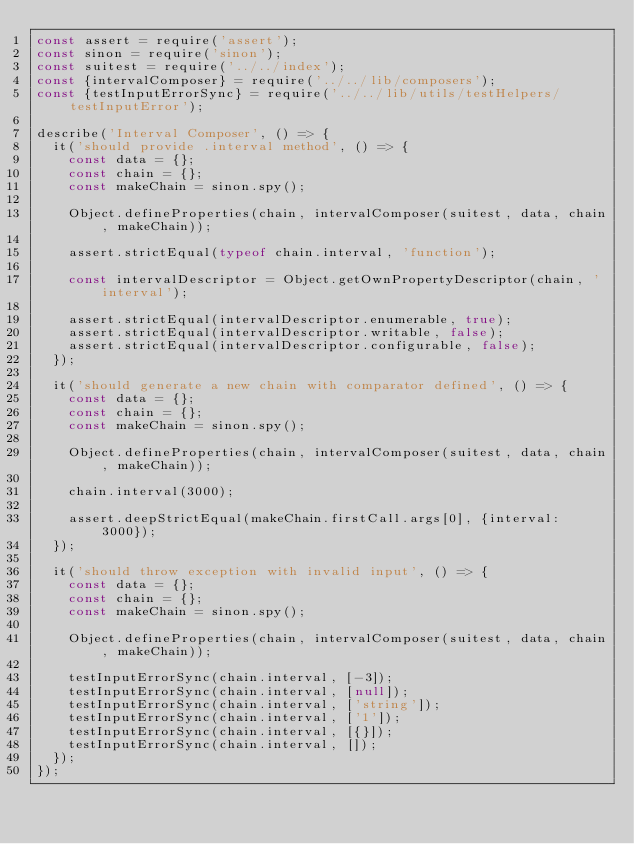Convert code to text. <code><loc_0><loc_0><loc_500><loc_500><_JavaScript_>const assert = require('assert');
const sinon = require('sinon');
const suitest = require('../../index');
const {intervalComposer} = require('../../lib/composers');
const {testInputErrorSync} = require('../../lib/utils/testHelpers/testInputError');

describe('Interval Composer', () => {
	it('should provide .interval method', () => {
		const data = {};
		const chain = {};
		const makeChain = sinon.spy();

		Object.defineProperties(chain, intervalComposer(suitest, data, chain, makeChain));

		assert.strictEqual(typeof chain.interval, 'function');

		const intervalDescriptor = Object.getOwnPropertyDescriptor(chain, 'interval');

		assert.strictEqual(intervalDescriptor.enumerable, true);
		assert.strictEqual(intervalDescriptor.writable, false);
		assert.strictEqual(intervalDescriptor.configurable, false);
	});

	it('should generate a new chain with comparator defined', () => {
		const data = {};
		const chain = {};
		const makeChain = sinon.spy();

		Object.defineProperties(chain, intervalComposer(suitest, data, chain, makeChain));

		chain.interval(3000);

		assert.deepStrictEqual(makeChain.firstCall.args[0], {interval: 3000});
	});

	it('should throw exception with invalid input', () => {
		const data = {};
		const chain = {};
		const makeChain = sinon.spy();

		Object.defineProperties(chain, intervalComposer(suitest, data, chain, makeChain));

		testInputErrorSync(chain.interval, [-3]);
		testInputErrorSync(chain.interval, [null]);
		testInputErrorSync(chain.interval, ['string']);
		testInputErrorSync(chain.interval, ['1']);
		testInputErrorSync(chain.interval, [{}]);
		testInputErrorSync(chain.interval, []);
	});
});
</code> 